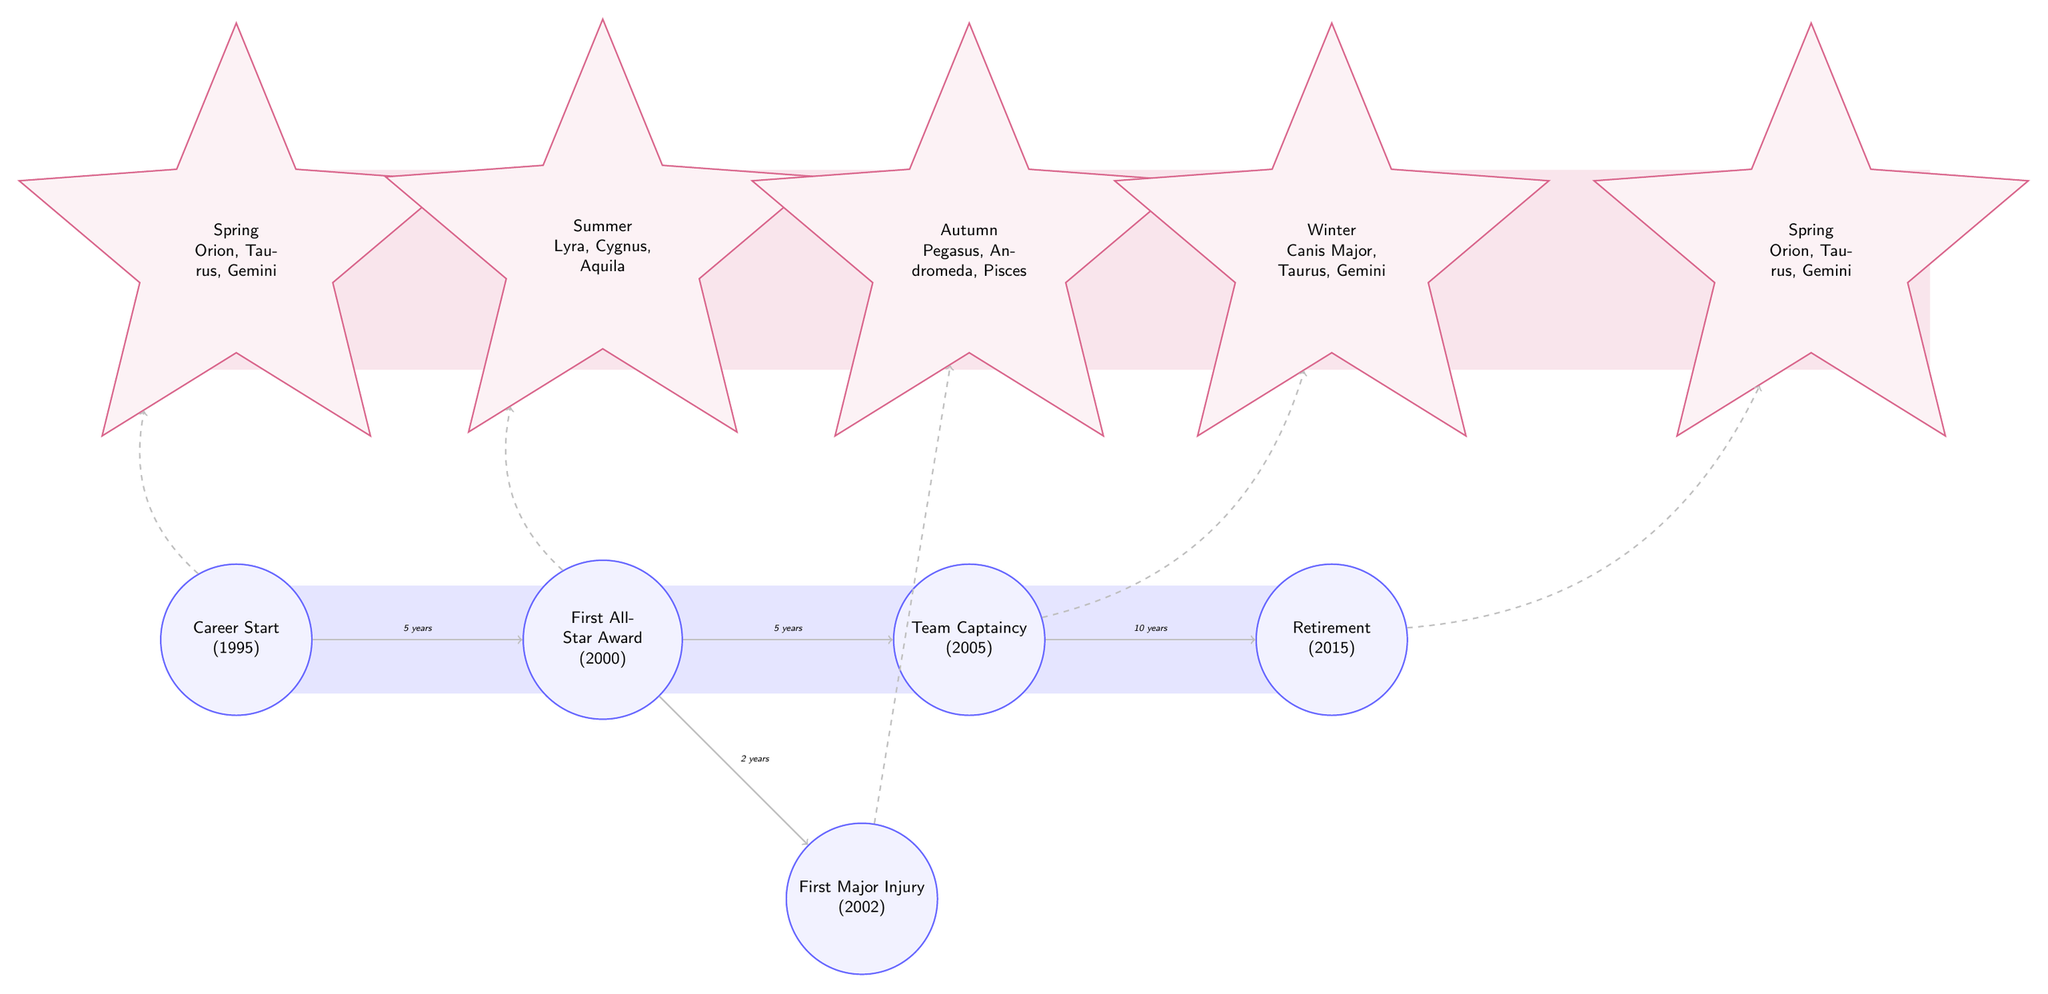What career event occurs closest to 2000? Looking at the timeline in the diagram, the first All-Star Award event is listed as occurring in 2000, and it is placed immediately next to the career start event in 1995, marking it as the nearest significant event.
Answer: First All-Star Award Which celestial bodies are associated with summer? The diagram specifies that the summer season includes the constellations of Lyra, Cygnus, and Aquila. These names are associated with the summer node directly in the diagram.
Answer: Lyra, Cygnus, Aquila What is the time gap between the first All-Star award and the first major injury? The diagram clearly shows a path from the first All-Star Award in 2000 to the first Major Injury in 2002, indicating a time gap of 2 years between these two events.
Answer: 2 years Which event comes just before retirement? Analyzing the timeline, we see that the Team Captaincy event in 2005 directly precedes the Retirement event in 2015, making it the last major career event before retirement.
Answer: Team Captaincy In which celestial season does the first major injury fall? The diagram indicates that the first Major Injury, which occurred in 2002, is associated with the autumn season, as represented above that event in the diagram layout.
Answer: Autumn How many total career events are illustrated in the diagram? By counting the events represented in the career section of the diagram, there are a total of five major career events presented.
Answer: 5 What is the duration of the player's career from start to retirement? The diagram indicates the career start in 1995 and retirement in 2015. By calculating the difference between these two years, we determine that the total career duration is 20 years.
Answer: 20 years Which celestial body appears in both spring and winter? The diagram reveals that Taurus is mentioned within both the spring and winter celestial nodes, making it the shared constellation between these two seasonal representations.
Answer: Taurus What period follows the Team Captaincy event? Analyzing the diagram, the path originating from the Team Captaincy event in 2005 leads directly to the Retirement event in 2015, indicating a period of 10 years following the captaincy.
Answer: 10 years 